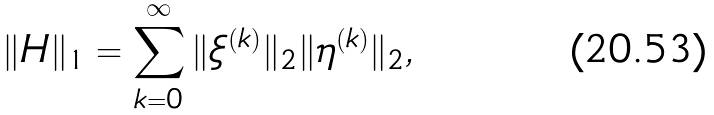Convert formula to latex. <formula><loc_0><loc_0><loc_500><loc_500>\| H \| _ { 1 } = \sum _ { k = 0 } ^ { \infty } \| \xi ^ { ( k ) } \| _ { 2 } \| \eta ^ { ( k ) } \| _ { 2 } ,</formula> 